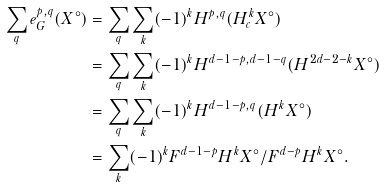Convert formula to latex. <formula><loc_0><loc_0><loc_500><loc_500>\sum _ { q } e ^ { p , q } _ { G } ( X ^ { \circ } ) & = \sum _ { q } \sum _ { k } ( - 1 ) ^ { k } H ^ { p , q } ( H ^ { k } _ { c } X ^ { \circ } ) \\ & = \sum _ { q } \sum _ { k } ( - 1 ) ^ { k } H ^ { d - 1 - p , d - 1 - q } ( H ^ { 2 d - 2 - k } X ^ { \circ } ) \\ & = \sum _ { q } \sum _ { k } ( - 1 ) ^ { k } H ^ { d - 1 - p , q } ( H ^ { k } X ^ { \circ } ) \\ & = \sum _ { k } ( - 1 ) ^ { k } F ^ { d - 1 - p } H ^ { k } X ^ { \circ } / F ^ { d - p } H ^ { k } X ^ { \circ } .</formula> 